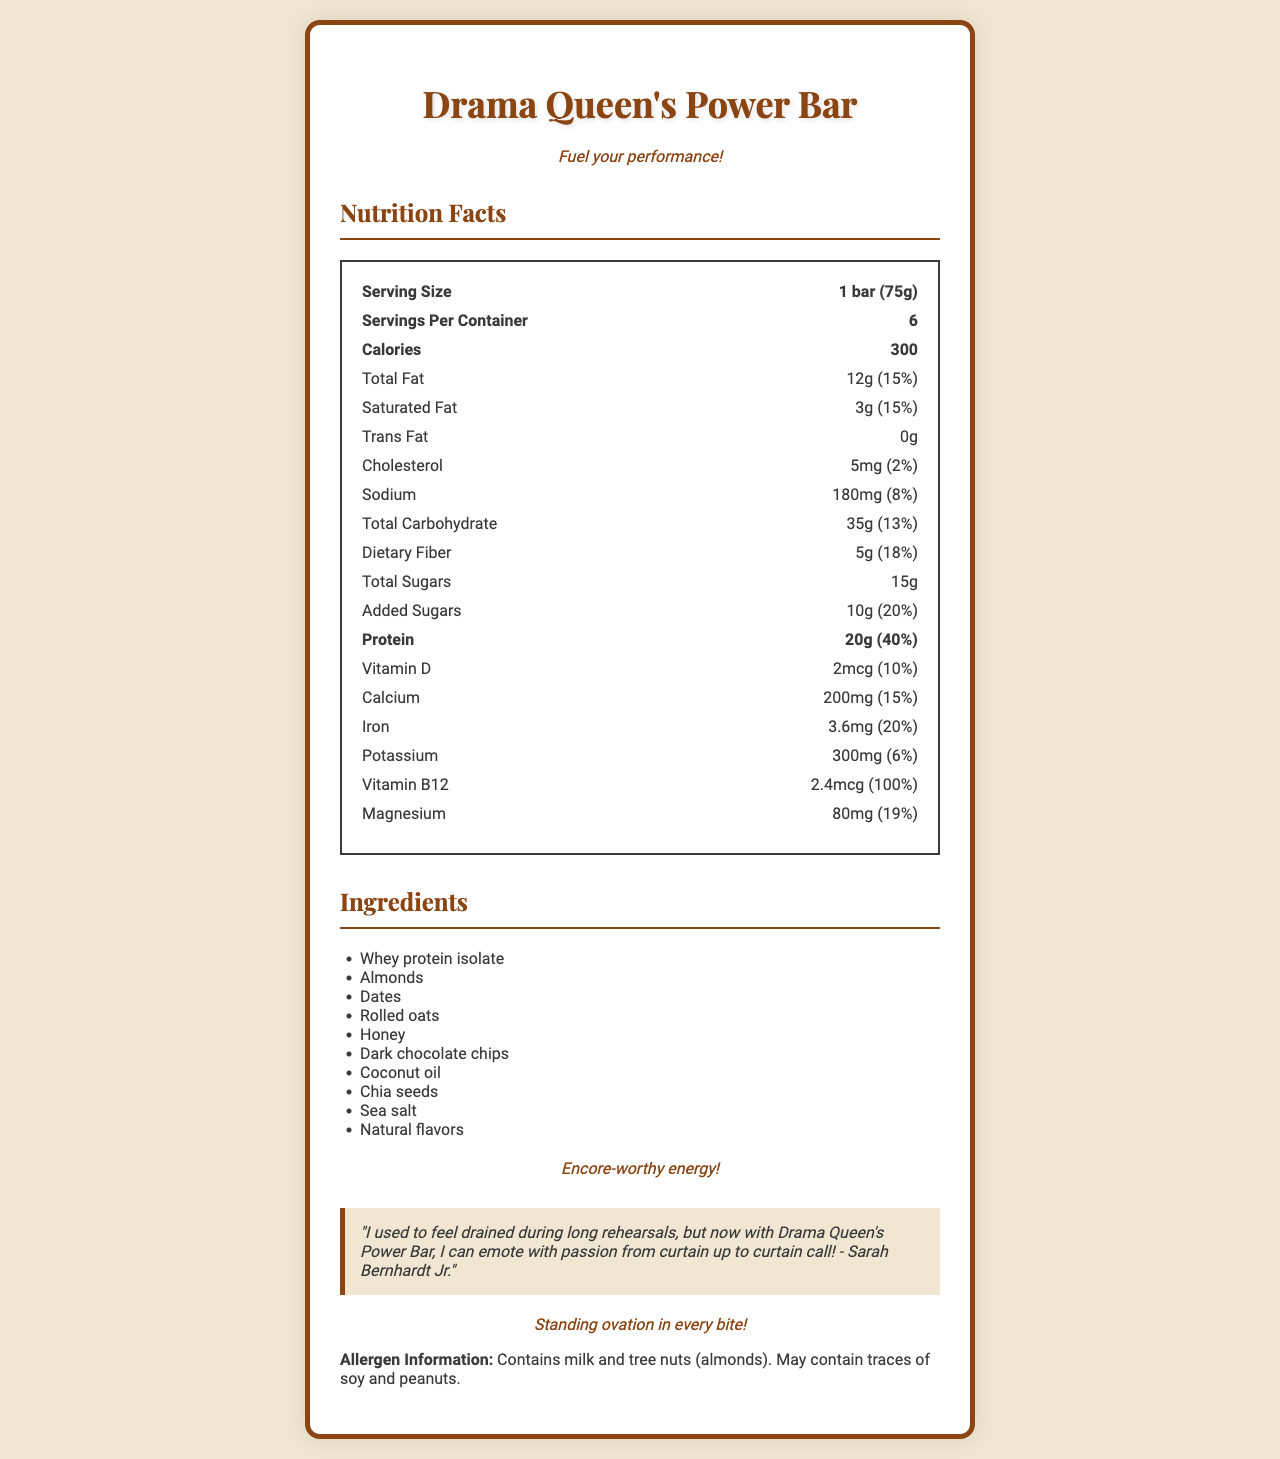What is the serving size for Drama Queen's Power Bar? The serving size is clearly listed as 1 bar (75g) within the nutrition facts section.
Answer: 1 bar (75g) How many servings are there per container? The document specifies that there are 6 servings per container.
Answer: 6 How many grams of protein does each bar contain? The nutrition facts show that each serving contains 20 grams of protein.
Answer: 20g What is the total fat content per serving, and its percent daily value? The total fat content per serving is 12 grams, which is 15% of the daily value.
Answer: 12g, 15% What allergens are present in this product? The allergen information section lists milk and tree nuts (almonds) as allergens.
Answer: Milk and tree nuts (almonds) What is the amount of added sugars in each bar? The nutrition facts state that there are 10 grams of added sugars per serving.
Answer: 10g Which vitamin has the highest percent daily value? A. Vitamin D B. Calcium C. Vitamin B12 D. Iron Vitamin B12 has the highest percent daily value at 100%.
Answer: C How much dietary fiber is in each serving? A. 3g B. 5g C. 8g D. 10g The document states that each serving has 5 grams of dietary fiber.
Answer: B Does Drama Queen's Power Bar contain any trans fat? The nutrition facts explicitly state that the product contains 0 grams of trans fat.
Answer: No How many calories does each bar contain? Each bar contains 300 calories, as indicated in the nutrition facts section.
Answer: 300 Summarize the document in one sentence. The document provides comprehensive information about the protein bar, including its nutritional content, ingredients, allergen information, and marketing taglines aimed at actors.
Answer: The document details the nutritional information, ingredients, allergens, and dramatic taglines of "Drama Queen's Power Bar," a high-energy protein bar designed to sustain actors during long performances. Is there any information about the product's taste? The document does not provide any information regarding the taste of the product.
Answer: No What is the font used for the product name in the document? The font choice for the product name is specified as Broadway.
Answer: Broadway How much sodium does each bar contain, and what is its percent daily value? The document lists the sodium content as 180mg, which is 8% of the daily value.
Answer: 180mg, 8% What is the testimonial about Drama Queen's Power Bar? The document includes a testimonial that credits the bar with helping sustain energy during long rehearsals.
Answer: "I used to feel drained during long rehearsals, but now with Drama Queen's Power Bar, I can emote with passion from curtain up to curtain call! - Sarah Bernhardt Jr." Does the document mention the price of Drama Queen's Power Bar? The document does not include any information about the price of the product.
Answer: No 